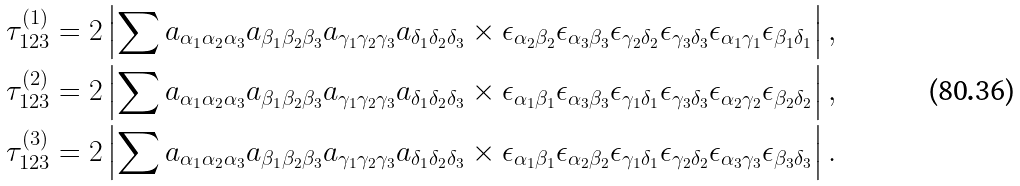Convert formula to latex. <formula><loc_0><loc_0><loc_500><loc_500>\tau _ { 1 2 3 } ^ { ( 1 ) } & = 2 \left | \sum a _ { \alpha _ { 1 } \alpha _ { 2 } \alpha _ { 3 } } a _ { \beta _ { 1 } \beta _ { 2 } \beta _ { 3 } } a _ { \gamma _ { 1 } \gamma _ { 2 } \gamma _ { 3 } } a _ { \delta _ { 1 } \delta _ { 2 } \delta _ { 3 } } \times \epsilon _ { \alpha _ { 2 } \beta _ { 2 } } \epsilon _ { \alpha _ { 3 } \beta _ { 3 } } \epsilon _ { \gamma _ { 2 } \delta _ { 2 } } \epsilon _ { \gamma _ { 3 } \delta _ { 3 } } \epsilon _ { \alpha _ { 1 } \gamma _ { 1 } } \epsilon _ { \beta _ { 1 } \delta _ { 1 } } \right | , \\ \tau _ { 1 2 3 } ^ { ( 2 ) } & = 2 \left | \sum a _ { \alpha _ { 1 } \alpha _ { 2 } \alpha _ { 3 } } a _ { \beta _ { 1 } \beta _ { 2 } \beta _ { 3 } } a _ { \gamma _ { 1 } \gamma _ { 2 } \gamma _ { 3 } } a _ { \delta _ { 1 } \delta _ { 2 } \delta _ { 3 } } \times \epsilon _ { \alpha _ { 1 } \beta _ { 1 } } \epsilon _ { \alpha _ { 3 } \beta _ { 3 } } \epsilon _ { \gamma _ { 1 } \delta _ { 1 } } \epsilon _ { \gamma _ { 3 } \delta _ { 3 } } \epsilon _ { \alpha _ { 2 } \gamma _ { 2 } } \epsilon _ { \beta _ { 2 } \delta _ { 2 } } \right | , \\ \tau _ { 1 2 3 } ^ { ( 3 ) } & = 2 \left | \sum a _ { \alpha _ { 1 } \alpha _ { 2 } \alpha _ { 3 } } a _ { \beta _ { 1 } \beta _ { 2 } \beta _ { 3 } } a _ { \gamma _ { 1 } \gamma _ { 2 } \gamma _ { 3 } } a _ { \delta _ { 1 } \delta _ { 2 } \delta _ { 3 } } \times \epsilon _ { \alpha _ { 1 } \beta _ { 1 } } \epsilon _ { \alpha _ { 2 } \beta _ { 2 } } \epsilon _ { \gamma _ { 1 } \delta _ { 1 } } \epsilon _ { \gamma _ { 2 } \delta _ { 2 } } \epsilon _ { \alpha _ { 3 } \gamma _ { 3 } } \epsilon _ { \beta _ { 3 } \delta _ { 3 } } \right | .</formula> 